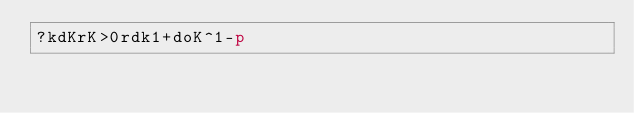Convert code to text. <code><loc_0><loc_0><loc_500><loc_500><_dc_>?kdKrK>0rdk1+doK^1-p</code> 